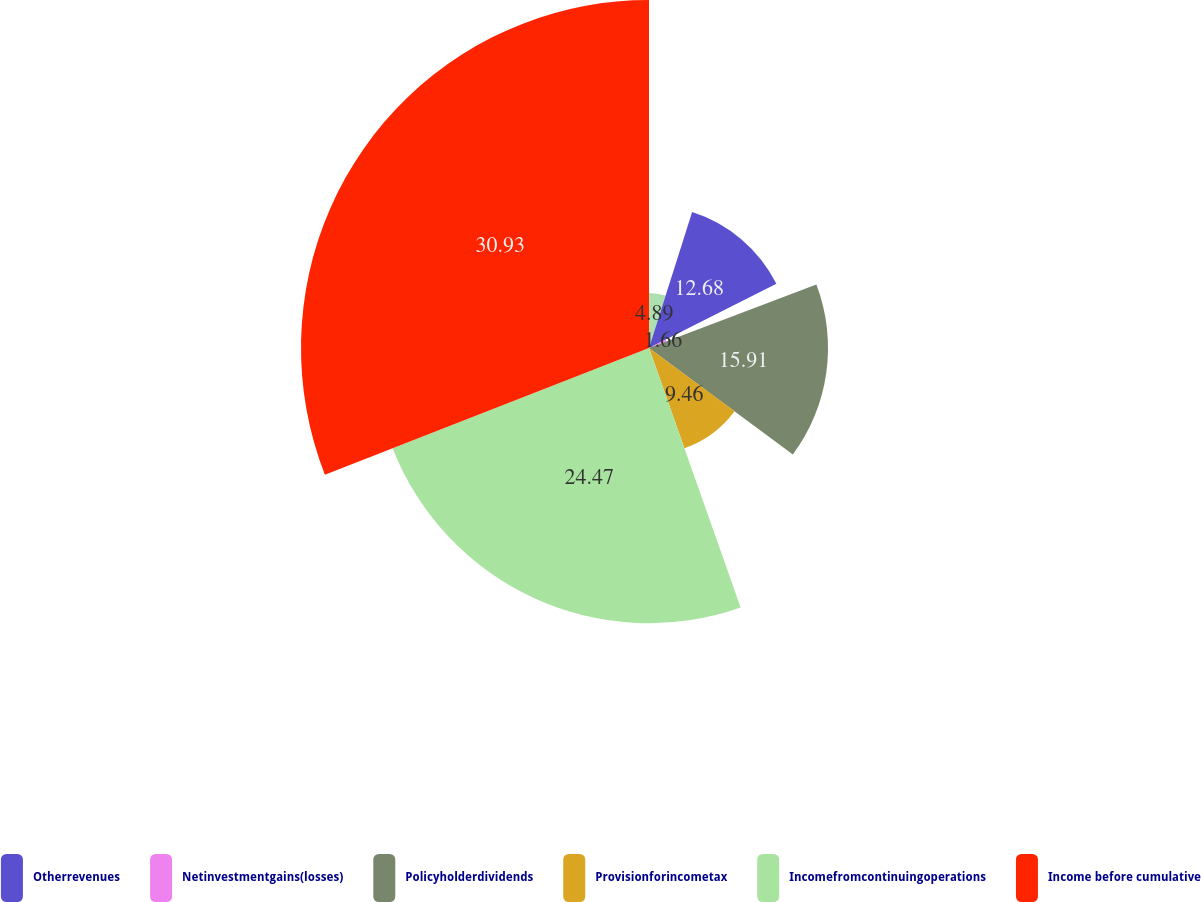Convert chart. <chart><loc_0><loc_0><loc_500><loc_500><pie_chart><ecel><fcel>Otherrevenues<fcel>Netinvestmentgains(losses)<fcel>Policyholderdividends<fcel>Provisionforincometax<fcel>Incomefromcontinuingoperations<fcel>Income before cumulative<nl><fcel>4.89%<fcel>12.68%<fcel>1.66%<fcel>15.91%<fcel>9.46%<fcel>24.47%<fcel>30.93%<nl></chart> 